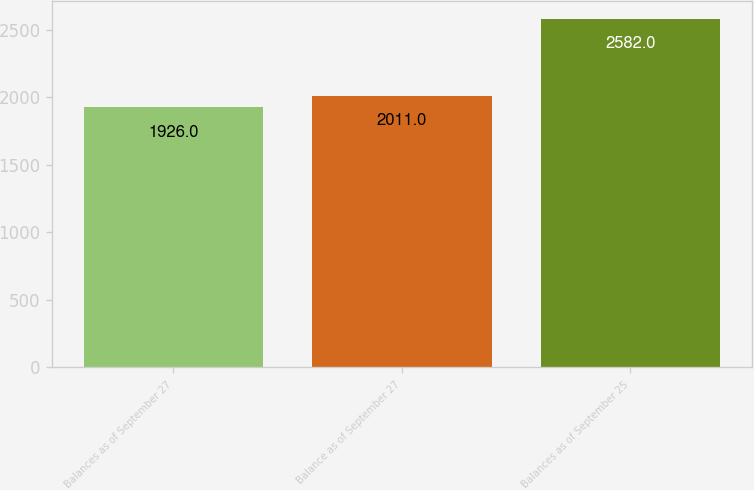Convert chart to OTSL. <chart><loc_0><loc_0><loc_500><loc_500><bar_chart><fcel>Balances as of September 27<fcel>Balance as of September 27<fcel>Balances as of September 25<nl><fcel>1926<fcel>2011<fcel>2582<nl></chart> 